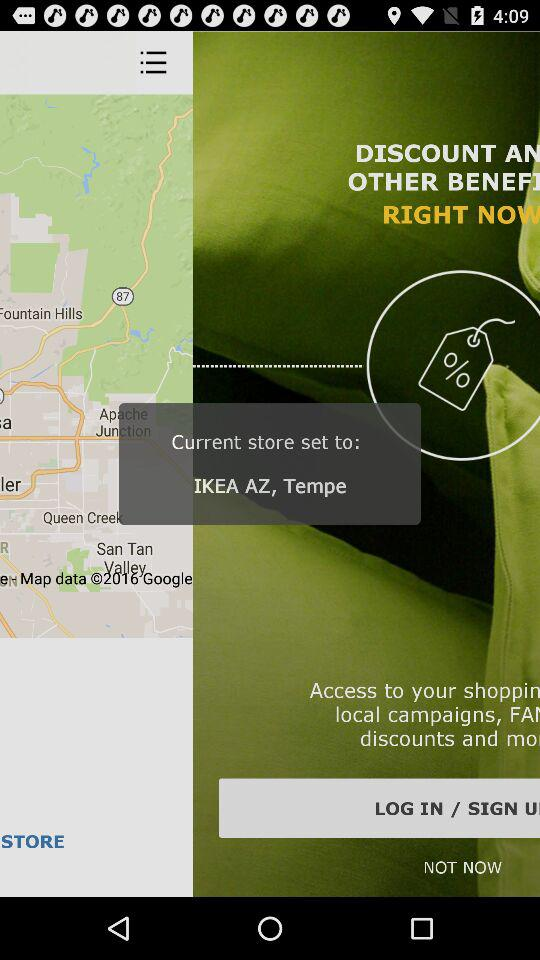Where has the current store been set? The current store has been set up in Tempe, Arizona. 